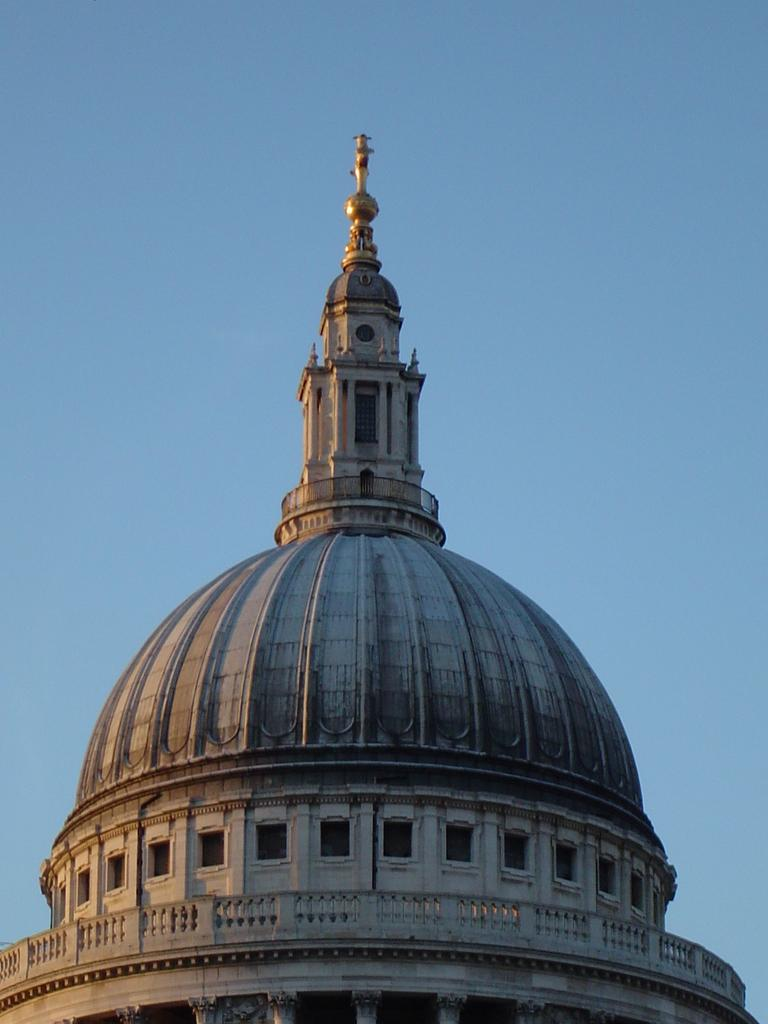What is the main subject in the picture? There is a building in the picture. What can be seen in the background of the picture? The sky is visible in the background of the picture. How many bears are visible in the picture? There are no bears present in the picture. What emotion is the building expressing in the picture? Buildings do not have emotions, so this question cannot be answered. 